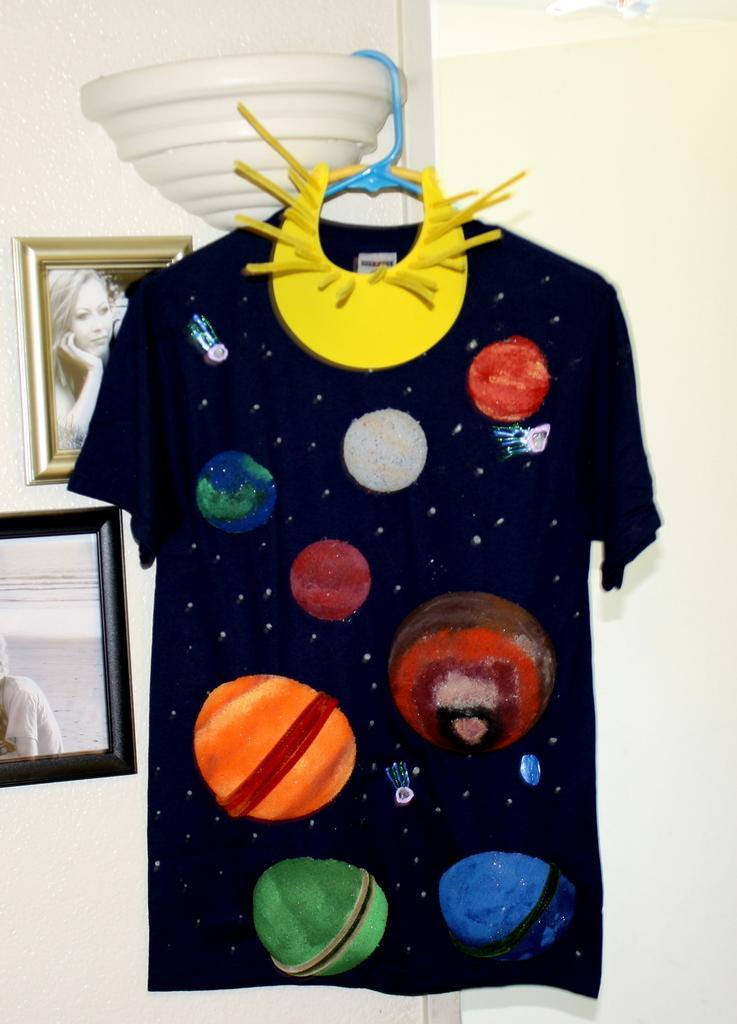Describe this image in one or two sentences. In this image I see a t-shirt which is of black in color and I see the round things which are of different in colors and I see that this t-shirt is hanged to this white color thing and I see the yellow color thing over here. In the background I see the wall on which there are 2 photo frames and in this photo I see a woman. 